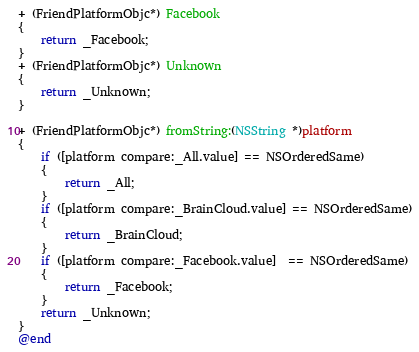Convert code to text. <code><loc_0><loc_0><loc_500><loc_500><_ObjectiveC_>+ (FriendPlatformObjc*) Facebook
{
    return _Facebook;
}
+ (FriendPlatformObjc*) Unknown
{
    return _Unknown;
}

+ (FriendPlatformObjc*) fromString:(NSString *)platform
{
    if ([platform compare:_All.value] == NSOrderedSame)
    {
        return _All;
    }
    if ([platform compare:_BrainCloud.value] == NSOrderedSame)
    {
        return _BrainCloud;
    }
    if ([platform compare:_Facebook.value]  == NSOrderedSame)
    {
        return _Facebook;
    }
    return _Unknown;
}
@end

</code> 